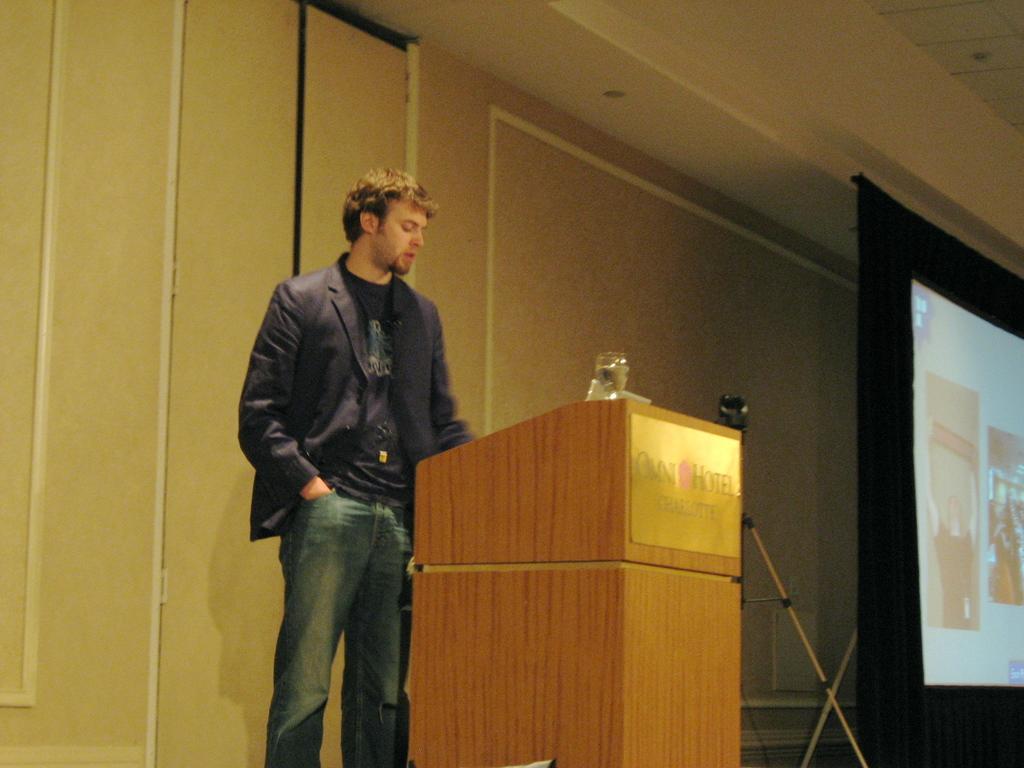How would you summarize this image in a sentence or two? In the image there is a man in jacket and jeans standing in front of dias, on the right side there is a screen in front of the wall. 